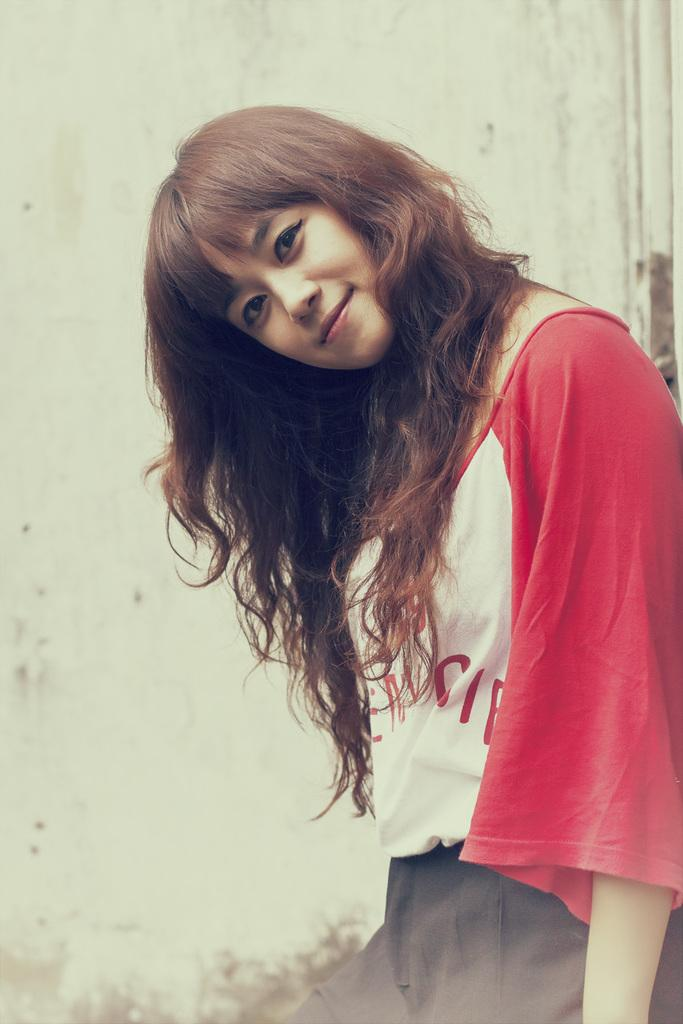What can be seen in the background of the image? There is a wall in the background of the image. Who is the main subject in the image? There is a girl in the image. What is the girl doing in the image? The girl is smiling and giving a pose. Are there any men lifting heavy objects in the image? There are no men or heavy objects being lifted in the image; it features a girl giving a pose with a wall in the background. 